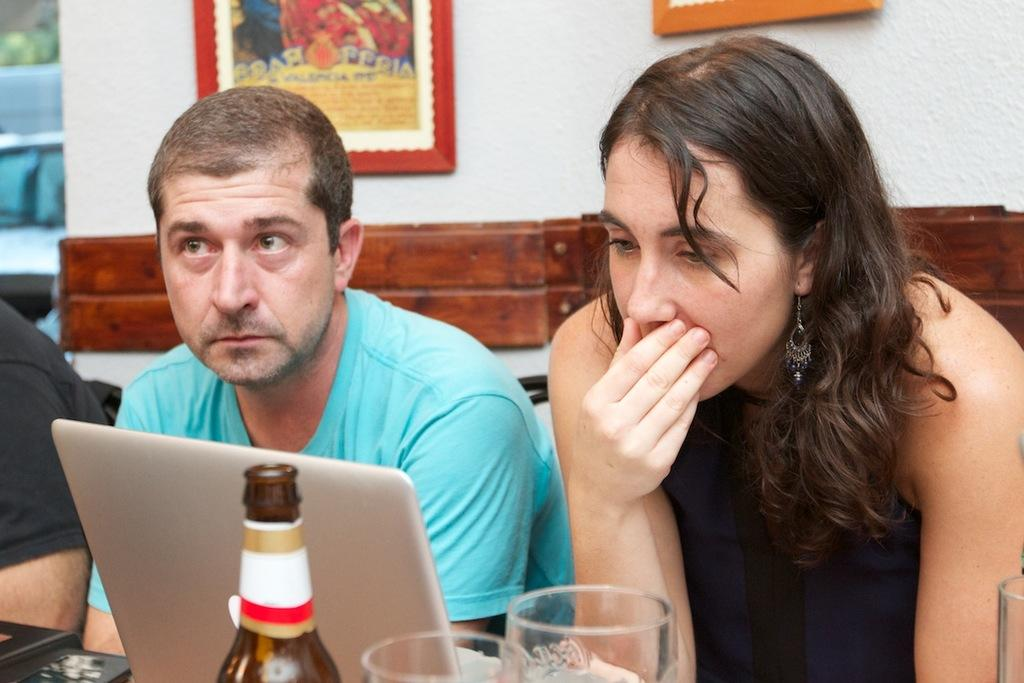What can be seen on the wall in the background of the image? There are frames on a wall in the background. What are the people in the image doing? There is a woman sitting on a chair and a man sitting on a chair. Where are the chairs located in relation to the table? The chairs are in front of a table. What electronic device is on the table? There is a laptop on the table. What other objects are on the table? There is a bottle and glasses on the table. What is the feeling of the group in the image? There is no group present in the image, and therefore no collective feeling can be determined. Who is the owner of the laptop in the image? The image does not provide information about the ownership of the laptop, so it cannot be determined from the image. 